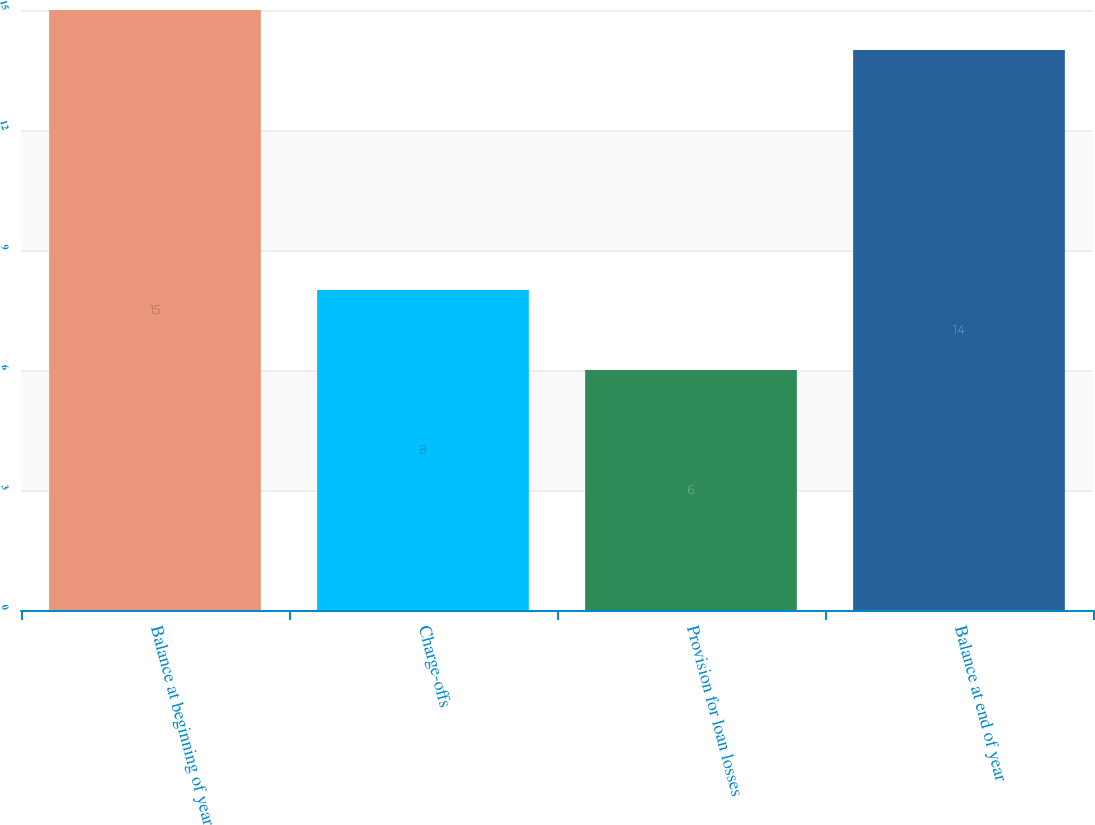Convert chart. <chart><loc_0><loc_0><loc_500><loc_500><bar_chart><fcel>Balance at beginning of year<fcel>Charge-offs<fcel>Provision for loan losses<fcel>Balance at end of year<nl><fcel>15<fcel>8<fcel>6<fcel>14<nl></chart> 